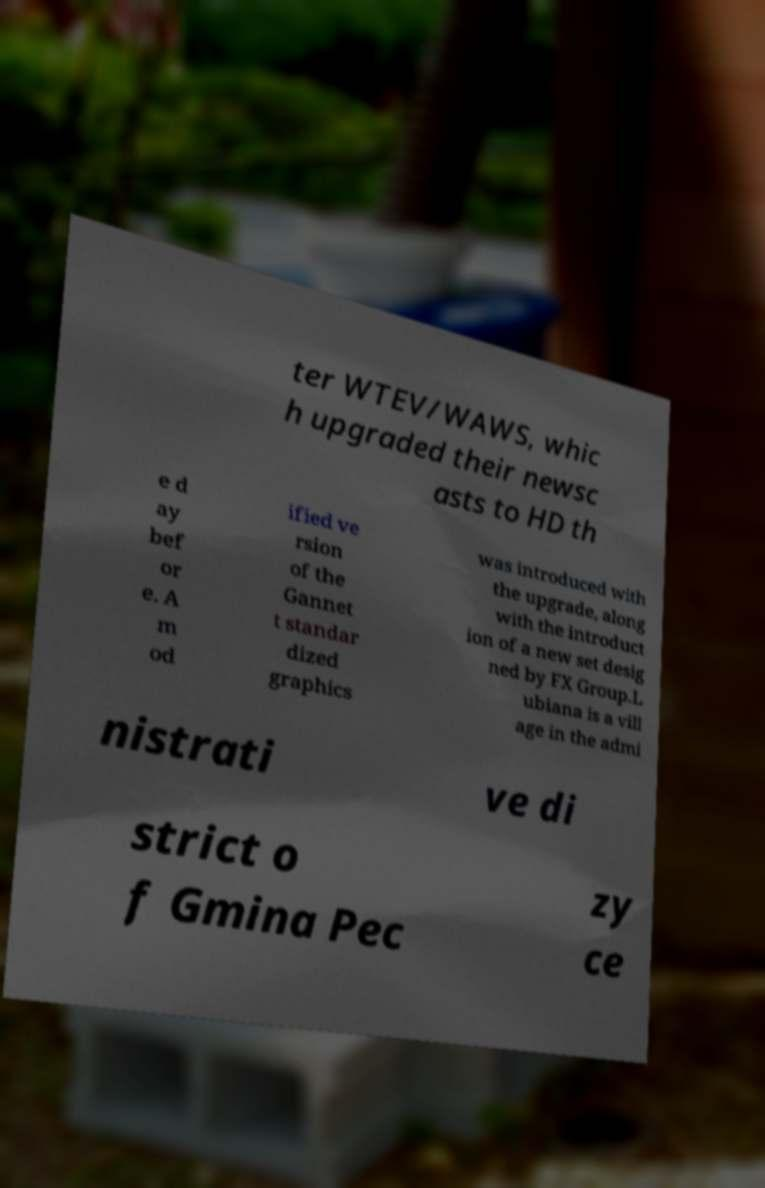What messages or text are displayed in this image? I need them in a readable, typed format. ter WTEV/WAWS, whic h upgraded their newsc asts to HD th e d ay bef or e. A m od ified ve rsion of the Gannet t standar dized graphics was introduced with the upgrade, along with the introduct ion of a new set desig ned by FX Group.L ubiana is a vill age in the admi nistrati ve di strict o f Gmina Pec zy ce 